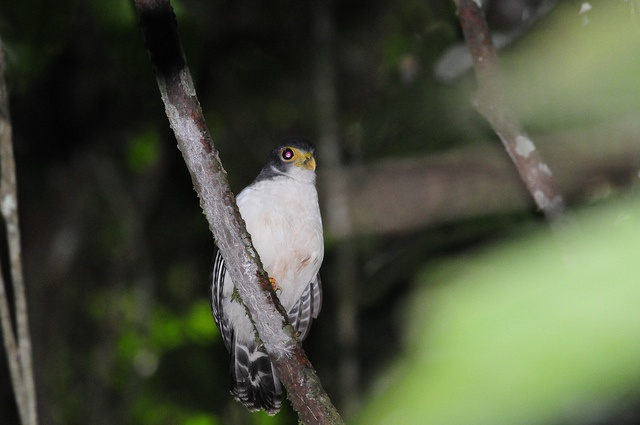Describe the objects in this image and their specific colors. I can see a bird in black, darkgray, lightgray, and gray tones in this image. 